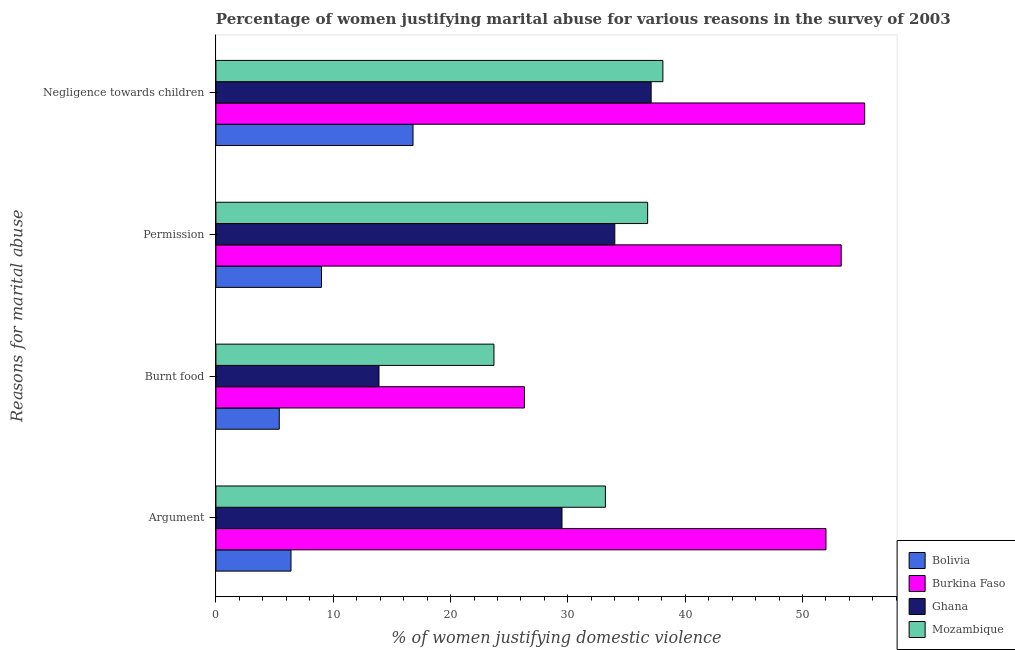How many different coloured bars are there?
Keep it short and to the point. 4. How many groups of bars are there?
Ensure brevity in your answer.  4. Are the number of bars on each tick of the Y-axis equal?
Give a very brief answer. Yes. How many bars are there on the 1st tick from the top?
Provide a succinct answer. 4. What is the label of the 2nd group of bars from the top?
Provide a succinct answer. Permission. What is the percentage of women justifying abuse in the case of an argument in Ghana?
Your answer should be compact. 29.5. Across all countries, what is the minimum percentage of women justifying abuse for burning food?
Offer a terse response. 5.4. In which country was the percentage of women justifying abuse for burning food maximum?
Make the answer very short. Burkina Faso. In which country was the percentage of women justifying abuse for burning food minimum?
Offer a terse response. Bolivia. What is the total percentage of women justifying abuse for showing negligence towards children in the graph?
Offer a very short reply. 147.3. What is the difference between the percentage of women justifying abuse for going without permission in Bolivia and that in Burkina Faso?
Your response must be concise. -44.3. What is the average percentage of women justifying abuse for showing negligence towards children per country?
Provide a short and direct response. 36.82. What is the difference between the percentage of women justifying abuse for showing negligence towards children and percentage of women justifying abuse in the case of an argument in Burkina Faso?
Keep it short and to the point. 3.3. In how many countries, is the percentage of women justifying abuse for showing negligence towards children greater than 10 %?
Your answer should be very brief. 4. What is the ratio of the percentage of women justifying abuse for burning food in Mozambique to that in Ghana?
Keep it short and to the point. 1.71. Is the percentage of women justifying abuse for showing negligence towards children in Burkina Faso less than that in Ghana?
Give a very brief answer. No. Is the difference between the percentage of women justifying abuse in the case of an argument in Mozambique and Bolivia greater than the difference between the percentage of women justifying abuse for showing negligence towards children in Mozambique and Bolivia?
Provide a succinct answer. Yes. What is the difference between the highest and the second highest percentage of women justifying abuse for showing negligence towards children?
Ensure brevity in your answer.  17.2. What is the difference between the highest and the lowest percentage of women justifying abuse for showing negligence towards children?
Provide a succinct answer. 38.5. In how many countries, is the percentage of women justifying abuse for going without permission greater than the average percentage of women justifying abuse for going without permission taken over all countries?
Offer a terse response. 3. Is the sum of the percentage of women justifying abuse for going without permission in Mozambique and Ghana greater than the maximum percentage of women justifying abuse for showing negligence towards children across all countries?
Your answer should be very brief. Yes. Is it the case that in every country, the sum of the percentage of women justifying abuse for going without permission and percentage of women justifying abuse in the case of an argument is greater than the sum of percentage of women justifying abuse for burning food and percentage of women justifying abuse for showing negligence towards children?
Offer a terse response. No. What does the 3rd bar from the top in Argument represents?
Give a very brief answer. Burkina Faso. What does the 4th bar from the bottom in Argument represents?
Make the answer very short. Mozambique. How many bars are there?
Give a very brief answer. 16. Are all the bars in the graph horizontal?
Ensure brevity in your answer.  Yes. How many countries are there in the graph?
Offer a terse response. 4. What is the difference between two consecutive major ticks on the X-axis?
Keep it short and to the point. 10. Are the values on the major ticks of X-axis written in scientific E-notation?
Provide a succinct answer. No. What is the title of the graph?
Ensure brevity in your answer.  Percentage of women justifying marital abuse for various reasons in the survey of 2003. What is the label or title of the X-axis?
Your answer should be very brief. % of women justifying domestic violence. What is the label or title of the Y-axis?
Provide a succinct answer. Reasons for marital abuse. What is the % of women justifying domestic violence in Bolivia in Argument?
Your answer should be compact. 6.4. What is the % of women justifying domestic violence in Burkina Faso in Argument?
Ensure brevity in your answer.  52. What is the % of women justifying domestic violence in Ghana in Argument?
Make the answer very short. 29.5. What is the % of women justifying domestic violence in Mozambique in Argument?
Offer a terse response. 33.2. What is the % of women justifying domestic violence of Bolivia in Burnt food?
Make the answer very short. 5.4. What is the % of women justifying domestic violence in Burkina Faso in Burnt food?
Your answer should be compact. 26.3. What is the % of women justifying domestic violence of Ghana in Burnt food?
Offer a very short reply. 13.9. What is the % of women justifying domestic violence in Mozambique in Burnt food?
Provide a short and direct response. 23.7. What is the % of women justifying domestic violence in Burkina Faso in Permission?
Offer a terse response. 53.3. What is the % of women justifying domestic violence in Mozambique in Permission?
Your answer should be very brief. 36.8. What is the % of women justifying domestic violence of Burkina Faso in Negligence towards children?
Offer a very short reply. 55.3. What is the % of women justifying domestic violence of Ghana in Negligence towards children?
Offer a terse response. 37.1. What is the % of women justifying domestic violence in Mozambique in Negligence towards children?
Offer a terse response. 38.1. Across all Reasons for marital abuse, what is the maximum % of women justifying domestic violence of Burkina Faso?
Provide a succinct answer. 55.3. Across all Reasons for marital abuse, what is the maximum % of women justifying domestic violence of Ghana?
Offer a terse response. 37.1. Across all Reasons for marital abuse, what is the maximum % of women justifying domestic violence in Mozambique?
Offer a terse response. 38.1. Across all Reasons for marital abuse, what is the minimum % of women justifying domestic violence in Burkina Faso?
Make the answer very short. 26.3. Across all Reasons for marital abuse, what is the minimum % of women justifying domestic violence in Mozambique?
Provide a short and direct response. 23.7. What is the total % of women justifying domestic violence of Bolivia in the graph?
Provide a succinct answer. 37.6. What is the total % of women justifying domestic violence in Burkina Faso in the graph?
Make the answer very short. 186.9. What is the total % of women justifying domestic violence in Ghana in the graph?
Offer a terse response. 114.5. What is the total % of women justifying domestic violence of Mozambique in the graph?
Your answer should be very brief. 131.8. What is the difference between the % of women justifying domestic violence of Bolivia in Argument and that in Burnt food?
Your response must be concise. 1. What is the difference between the % of women justifying domestic violence in Burkina Faso in Argument and that in Burnt food?
Keep it short and to the point. 25.7. What is the difference between the % of women justifying domestic violence of Bolivia in Argument and that in Permission?
Your response must be concise. -2.6. What is the difference between the % of women justifying domestic violence in Ghana in Argument and that in Permission?
Make the answer very short. -4.5. What is the difference between the % of women justifying domestic violence of Ghana in Argument and that in Negligence towards children?
Keep it short and to the point. -7.6. What is the difference between the % of women justifying domestic violence in Mozambique in Argument and that in Negligence towards children?
Keep it short and to the point. -4.9. What is the difference between the % of women justifying domestic violence of Ghana in Burnt food and that in Permission?
Make the answer very short. -20.1. What is the difference between the % of women justifying domestic violence in Mozambique in Burnt food and that in Permission?
Offer a terse response. -13.1. What is the difference between the % of women justifying domestic violence of Ghana in Burnt food and that in Negligence towards children?
Give a very brief answer. -23.2. What is the difference between the % of women justifying domestic violence of Mozambique in Burnt food and that in Negligence towards children?
Your answer should be very brief. -14.4. What is the difference between the % of women justifying domestic violence of Bolivia in Permission and that in Negligence towards children?
Offer a terse response. -7.8. What is the difference between the % of women justifying domestic violence in Ghana in Permission and that in Negligence towards children?
Ensure brevity in your answer.  -3.1. What is the difference between the % of women justifying domestic violence in Bolivia in Argument and the % of women justifying domestic violence in Burkina Faso in Burnt food?
Offer a very short reply. -19.9. What is the difference between the % of women justifying domestic violence of Bolivia in Argument and the % of women justifying domestic violence of Ghana in Burnt food?
Offer a very short reply. -7.5. What is the difference between the % of women justifying domestic violence in Bolivia in Argument and the % of women justifying domestic violence in Mozambique in Burnt food?
Keep it short and to the point. -17.3. What is the difference between the % of women justifying domestic violence of Burkina Faso in Argument and the % of women justifying domestic violence of Ghana in Burnt food?
Provide a succinct answer. 38.1. What is the difference between the % of women justifying domestic violence of Burkina Faso in Argument and the % of women justifying domestic violence of Mozambique in Burnt food?
Give a very brief answer. 28.3. What is the difference between the % of women justifying domestic violence of Bolivia in Argument and the % of women justifying domestic violence of Burkina Faso in Permission?
Give a very brief answer. -46.9. What is the difference between the % of women justifying domestic violence of Bolivia in Argument and the % of women justifying domestic violence of Ghana in Permission?
Keep it short and to the point. -27.6. What is the difference between the % of women justifying domestic violence of Bolivia in Argument and the % of women justifying domestic violence of Mozambique in Permission?
Make the answer very short. -30.4. What is the difference between the % of women justifying domestic violence of Burkina Faso in Argument and the % of women justifying domestic violence of Ghana in Permission?
Keep it short and to the point. 18. What is the difference between the % of women justifying domestic violence in Bolivia in Argument and the % of women justifying domestic violence in Burkina Faso in Negligence towards children?
Make the answer very short. -48.9. What is the difference between the % of women justifying domestic violence in Bolivia in Argument and the % of women justifying domestic violence in Ghana in Negligence towards children?
Keep it short and to the point. -30.7. What is the difference between the % of women justifying domestic violence of Bolivia in Argument and the % of women justifying domestic violence of Mozambique in Negligence towards children?
Ensure brevity in your answer.  -31.7. What is the difference between the % of women justifying domestic violence of Burkina Faso in Argument and the % of women justifying domestic violence of Ghana in Negligence towards children?
Provide a short and direct response. 14.9. What is the difference between the % of women justifying domestic violence of Burkina Faso in Argument and the % of women justifying domestic violence of Mozambique in Negligence towards children?
Keep it short and to the point. 13.9. What is the difference between the % of women justifying domestic violence in Bolivia in Burnt food and the % of women justifying domestic violence in Burkina Faso in Permission?
Make the answer very short. -47.9. What is the difference between the % of women justifying domestic violence of Bolivia in Burnt food and the % of women justifying domestic violence of Ghana in Permission?
Offer a terse response. -28.6. What is the difference between the % of women justifying domestic violence in Bolivia in Burnt food and the % of women justifying domestic violence in Mozambique in Permission?
Provide a short and direct response. -31.4. What is the difference between the % of women justifying domestic violence of Burkina Faso in Burnt food and the % of women justifying domestic violence of Ghana in Permission?
Provide a short and direct response. -7.7. What is the difference between the % of women justifying domestic violence in Ghana in Burnt food and the % of women justifying domestic violence in Mozambique in Permission?
Your answer should be very brief. -22.9. What is the difference between the % of women justifying domestic violence in Bolivia in Burnt food and the % of women justifying domestic violence in Burkina Faso in Negligence towards children?
Make the answer very short. -49.9. What is the difference between the % of women justifying domestic violence of Bolivia in Burnt food and the % of women justifying domestic violence of Ghana in Negligence towards children?
Provide a succinct answer. -31.7. What is the difference between the % of women justifying domestic violence of Bolivia in Burnt food and the % of women justifying domestic violence of Mozambique in Negligence towards children?
Make the answer very short. -32.7. What is the difference between the % of women justifying domestic violence of Burkina Faso in Burnt food and the % of women justifying domestic violence of Ghana in Negligence towards children?
Ensure brevity in your answer.  -10.8. What is the difference between the % of women justifying domestic violence in Burkina Faso in Burnt food and the % of women justifying domestic violence in Mozambique in Negligence towards children?
Give a very brief answer. -11.8. What is the difference between the % of women justifying domestic violence in Ghana in Burnt food and the % of women justifying domestic violence in Mozambique in Negligence towards children?
Your answer should be very brief. -24.2. What is the difference between the % of women justifying domestic violence of Bolivia in Permission and the % of women justifying domestic violence of Burkina Faso in Negligence towards children?
Make the answer very short. -46.3. What is the difference between the % of women justifying domestic violence in Bolivia in Permission and the % of women justifying domestic violence in Ghana in Negligence towards children?
Make the answer very short. -28.1. What is the difference between the % of women justifying domestic violence of Bolivia in Permission and the % of women justifying domestic violence of Mozambique in Negligence towards children?
Provide a short and direct response. -29.1. What is the difference between the % of women justifying domestic violence of Burkina Faso in Permission and the % of women justifying domestic violence of Ghana in Negligence towards children?
Provide a succinct answer. 16.2. What is the difference between the % of women justifying domestic violence in Burkina Faso in Permission and the % of women justifying domestic violence in Mozambique in Negligence towards children?
Offer a terse response. 15.2. What is the average % of women justifying domestic violence of Burkina Faso per Reasons for marital abuse?
Provide a short and direct response. 46.73. What is the average % of women justifying domestic violence in Ghana per Reasons for marital abuse?
Make the answer very short. 28.62. What is the average % of women justifying domestic violence in Mozambique per Reasons for marital abuse?
Offer a terse response. 32.95. What is the difference between the % of women justifying domestic violence of Bolivia and % of women justifying domestic violence of Burkina Faso in Argument?
Keep it short and to the point. -45.6. What is the difference between the % of women justifying domestic violence in Bolivia and % of women justifying domestic violence in Ghana in Argument?
Make the answer very short. -23.1. What is the difference between the % of women justifying domestic violence of Bolivia and % of women justifying domestic violence of Mozambique in Argument?
Your response must be concise. -26.8. What is the difference between the % of women justifying domestic violence of Burkina Faso and % of women justifying domestic violence of Mozambique in Argument?
Provide a succinct answer. 18.8. What is the difference between the % of women justifying domestic violence in Bolivia and % of women justifying domestic violence in Burkina Faso in Burnt food?
Provide a short and direct response. -20.9. What is the difference between the % of women justifying domestic violence in Bolivia and % of women justifying domestic violence in Ghana in Burnt food?
Your answer should be very brief. -8.5. What is the difference between the % of women justifying domestic violence of Bolivia and % of women justifying domestic violence of Mozambique in Burnt food?
Your answer should be very brief. -18.3. What is the difference between the % of women justifying domestic violence of Burkina Faso and % of women justifying domestic violence of Ghana in Burnt food?
Your answer should be very brief. 12.4. What is the difference between the % of women justifying domestic violence of Bolivia and % of women justifying domestic violence of Burkina Faso in Permission?
Your answer should be compact. -44.3. What is the difference between the % of women justifying domestic violence in Bolivia and % of women justifying domestic violence in Ghana in Permission?
Offer a terse response. -25. What is the difference between the % of women justifying domestic violence in Bolivia and % of women justifying domestic violence in Mozambique in Permission?
Ensure brevity in your answer.  -27.8. What is the difference between the % of women justifying domestic violence in Burkina Faso and % of women justifying domestic violence in Ghana in Permission?
Your answer should be compact. 19.3. What is the difference between the % of women justifying domestic violence in Ghana and % of women justifying domestic violence in Mozambique in Permission?
Ensure brevity in your answer.  -2.8. What is the difference between the % of women justifying domestic violence in Bolivia and % of women justifying domestic violence in Burkina Faso in Negligence towards children?
Offer a very short reply. -38.5. What is the difference between the % of women justifying domestic violence of Bolivia and % of women justifying domestic violence of Ghana in Negligence towards children?
Offer a very short reply. -20.3. What is the difference between the % of women justifying domestic violence of Bolivia and % of women justifying domestic violence of Mozambique in Negligence towards children?
Give a very brief answer. -21.3. What is the difference between the % of women justifying domestic violence of Ghana and % of women justifying domestic violence of Mozambique in Negligence towards children?
Keep it short and to the point. -1. What is the ratio of the % of women justifying domestic violence of Bolivia in Argument to that in Burnt food?
Offer a terse response. 1.19. What is the ratio of the % of women justifying domestic violence of Burkina Faso in Argument to that in Burnt food?
Your answer should be compact. 1.98. What is the ratio of the % of women justifying domestic violence in Ghana in Argument to that in Burnt food?
Provide a succinct answer. 2.12. What is the ratio of the % of women justifying domestic violence in Mozambique in Argument to that in Burnt food?
Offer a terse response. 1.4. What is the ratio of the % of women justifying domestic violence in Bolivia in Argument to that in Permission?
Ensure brevity in your answer.  0.71. What is the ratio of the % of women justifying domestic violence of Burkina Faso in Argument to that in Permission?
Ensure brevity in your answer.  0.98. What is the ratio of the % of women justifying domestic violence of Ghana in Argument to that in Permission?
Make the answer very short. 0.87. What is the ratio of the % of women justifying domestic violence of Mozambique in Argument to that in Permission?
Make the answer very short. 0.9. What is the ratio of the % of women justifying domestic violence in Bolivia in Argument to that in Negligence towards children?
Ensure brevity in your answer.  0.38. What is the ratio of the % of women justifying domestic violence of Burkina Faso in Argument to that in Negligence towards children?
Provide a short and direct response. 0.94. What is the ratio of the % of women justifying domestic violence of Ghana in Argument to that in Negligence towards children?
Your answer should be very brief. 0.8. What is the ratio of the % of women justifying domestic violence of Mozambique in Argument to that in Negligence towards children?
Ensure brevity in your answer.  0.87. What is the ratio of the % of women justifying domestic violence of Bolivia in Burnt food to that in Permission?
Give a very brief answer. 0.6. What is the ratio of the % of women justifying domestic violence in Burkina Faso in Burnt food to that in Permission?
Ensure brevity in your answer.  0.49. What is the ratio of the % of women justifying domestic violence of Ghana in Burnt food to that in Permission?
Ensure brevity in your answer.  0.41. What is the ratio of the % of women justifying domestic violence of Mozambique in Burnt food to that in Permission?
Your answer should be very brief. 0.64. What is the ratio of the % of women justifying domestic violence in Bolivia in Burnt food to that in Negligence towards children?
Ensure brevity in your answer.  0.32. What is the ratio of the % of women justifying domestic violence in Burkina Faso in Burnt food to that in Negligence towards children?
Keep it short and to the point. 0.48. What is the ratio of the % of women justifying domestic violence in Ghana in Burnt food to that in Negligence towards children?
Your answer should be compact. 0.37. What is the ratio of the % of women justifying domestic violence of Mozambique in Burnt food to that in Negligence towards children?
Your response must be concise. 0.62. What is the ratio of the % of women justifying domestic violence of Bolivia in Permission to that in Negligence towards children?
Keep it short and to the point. 0.54. What is the ratio of the % of women justifying domestic violence in Burkina Faso in Permission to that in Negligence towards children?
Make the answer very short. 0.96. What is the ratio of the % of women justifying domestic violence of Ghana in Permission to that in Negligence towards children?
Provide a short and direct response. 0.92. What is the ratio of the % of women justifying domestic violence in Mozambique in Permission to that in Negligence towards children?
Ensure brevity in your answer.  0.97. What is the difference between the highest and the second highest % of women justifying domestic violence in Mozambique?
Keep it short and to the point. 1.3. What is the difference between the highest and the lowest % of women justifying domestic violence of Ghana?
Offer a very short reply. 23.2. What is the difference between the highest and the lowest % of women justifying domestic violence of Mozambique?
Ensure brevity in your answer.  14.4. 